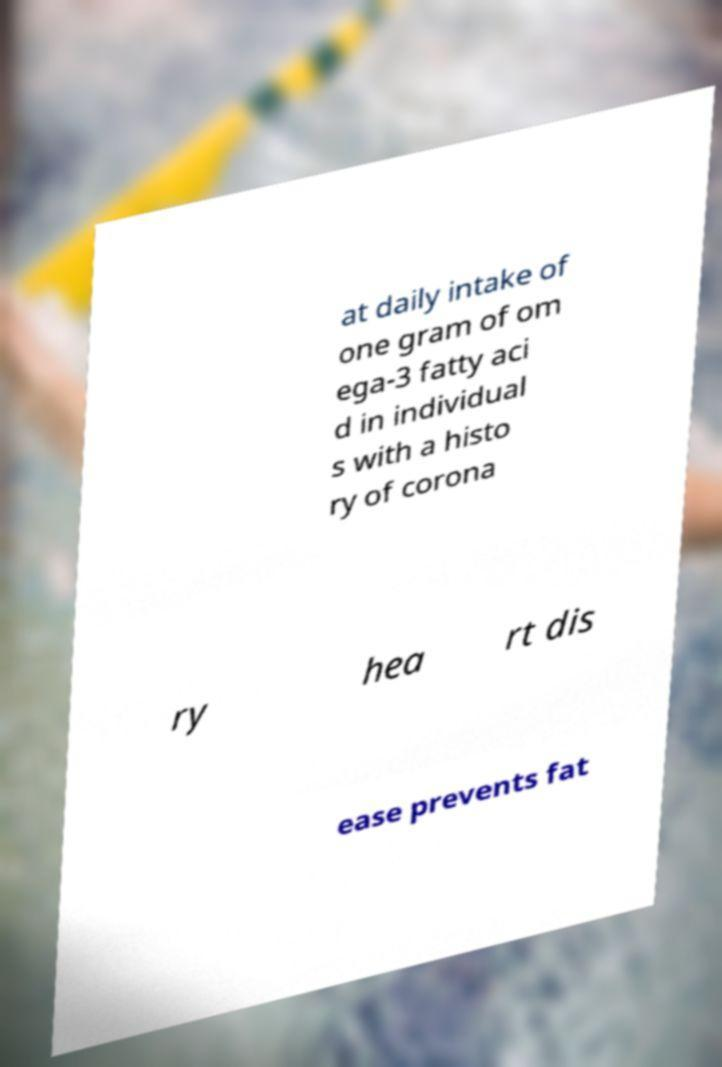There's text embedded in this image that I need extracted. Can you transcribe it verbatim? at daily intake of one gram of om ega-3 fatty aci d in individual s with a histo ry of corona ry hea rt dis ease prevents fat 